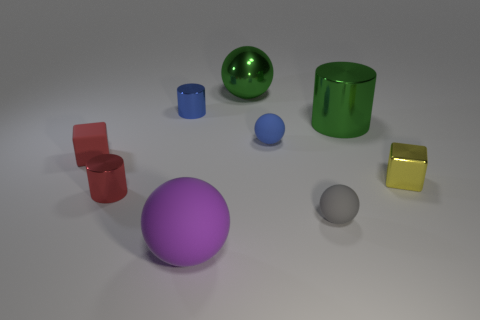Add 1 tiny matte cubes. How many objects exist? 10 Subtract all spheres. How many objects are left? 5 Subtract all brown shiny cylinders. Subtract all tiny blue matte spheres. How many objects are left? 8 Add 3 gray objects. How many gray objects are left? 4 Add 6 purple rubber things. How many purple rubber things exist? 7 Subtract 1 red cylinders. How many objects are left? 8 